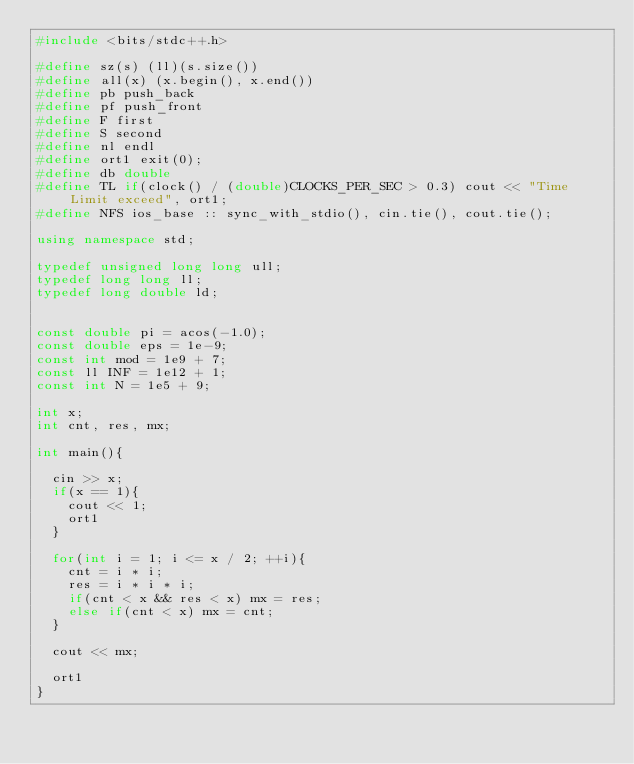Convert code to text. <code><loc_0><loc_0><loc_500><loc_500><_C++_>#include <bits/stdc++.h>
 
#define sz(s) (ll)(s.size())
#define all(x) (x.begin(), x.end())
#define pb push_back
#define pf push_front
#define F first
#define S second
#define nl endl
#define ort1 exit(0);
#define db double
#define TL if(clock() / (double)CLOCKS_PER_SEC > 0.3) cout << "Time Limit exceed", ort1;
#define NFS ios_base :: sync_with_stdio(), cin.tie(), cout.tie();  
 
using namespace std;
 
typedef unsigned long long ull;
typedef long long ll;
typedef long double ld;
 
 
const double pi = acos(-1.0);
const double eps = 1e-9;
const int mod = 1e9 + 7;
const ll INF = 1e12 + 1;
const int N = 1e5 + 9;
 
int x;
int cnt, res, mx;
 
int main(){
 
	cin >> x;
	if(x == 1){
		cout << 1;
		ort1
	}
	
	for(int i = 1; i <= x / 2; ++i){
		cnt = i * i;
		res = i * i * i;
		if(cnt < x && res < x) mx = res;
		else if(cnt < x) mx = cnt;
	}
 
	cout << mx;
 
	ort1
}</code> 